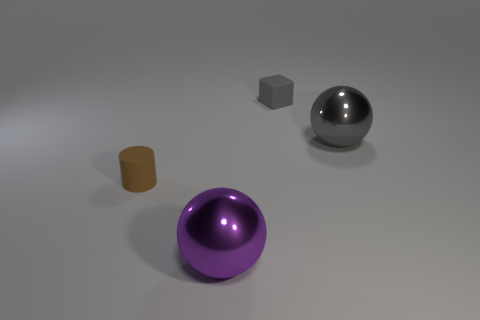What is the shape of the large thing on the right side of the gray cube?
Keep it short and to the point. Sphere. What number of green shiny objects are there?
Offer a very short reply. 0. Does the small brown object have the same material as the small block?
Keep it short and to the point. Yes. Are there more big objects on the right side of the tiny matte cube than tiny red shiny blocks?
Your answer should be compact. Yes. How many objects are either big purple matte blocks or matte things left of the block?
Ensure brevity in your answer.  1. Is the number of large gray shiny things behind the purple metal thing greater than the number of things that are behind the small gray matte cube?
Ensure brevity in your answer.  Yes. There is a large ball that is to the right of the large ball in front of the big metallic sphere that is right of the purple object; what is its material?
Provide a succinct answer. Metal. There is a large purple object that is made of the same material as the gray sphere; what is its shape?
Your response must be concise. Sphere. Is there a gray object that is in front of the large sphere that is behind the large purple ball?
Your answer should be very brief. No. What size is the purple object?
Keep it short and to the point. Large. 